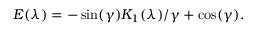Convert formula to latex. <formula><loc_0><loc_0><loc_500><loc_500>E ( \lambda ) = - \sin ( \gamma ) K _ { 1 } ( \lambda ) / \gamma + \cos ( \gamma ) .</formula> 